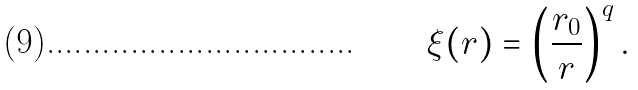Convert formula to latex. <formula><loc_0><loc_0><loc_500><loc_500>\xi ( r ) = \left ( \frac { r _ { 0 } } { r } \right ) ^ { q } .</formula> 